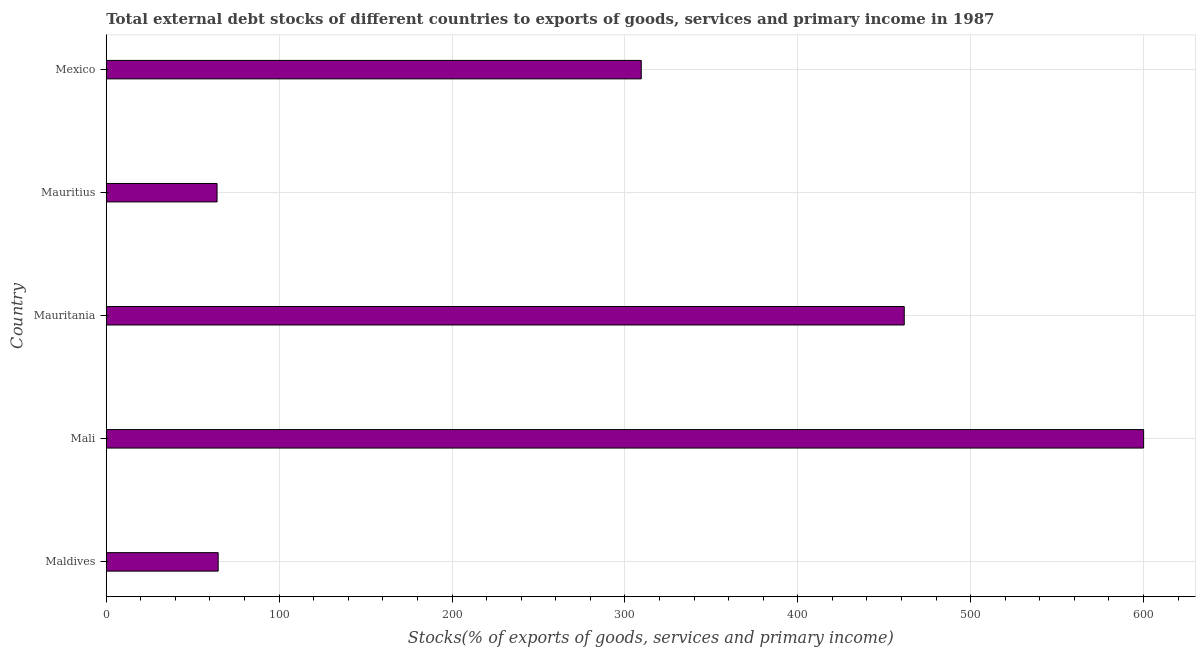Does the graph contain any zero values?
Your response must be concise. No. Does the graph contain grids?
Your answer should be compact. Yes. What is the title of the graph?
Offer a terse response. Total external debt stocks of different countries to exports of goods, services and primary income in 1987. What is the label or title of the X-axis?
Your response must be concise. Stocks(% of exports of goods, services and primary income). What is the external debt stocks in Mauritius?
Ensure brevity in your answer.  64.1. Across all countries, what is the maximum external debt stocks?
Provide a short and direct response. 600.04. Across all countries, what is the minimum external debt stocks?
Keep it short and to the point. 64.1. In which country was the external debt stocks maximum?
Your answer should be very brief. Mali. In which country was the external debt stocks minimum?
Keep it short and to the point. Mauritius. What is the sum of the external debt stocks?
Give a very brief answer. 1499.93. What is the difference between the external debt stocks in Mauritius and Mexico?
Make the answer very short. -245.37. What is the average external debt stocks per country?
Give a very brief answer. 299.99. What is the median external debt stocks?
Provide a short and direct response. 309.46. In how many countries, is the external debt stocks greater than 360 %?
Make the answer very short. 2. What is the ratio of the external debt stocks in Mauritania to that in Mauritius?
Provide a succinct answer. 7.2. Is the external debt stocks in Maldives less than that in Mauritius?
Provide a succinct answer. No. What is the difference between the highest and the second highest external debt stocks?
Give a very brief answer. 138.46. Is the sum of the external debt stocks in Maldives and Mauritius greater than the maximum external debt stocks across all countries?
Provide a succinct answer. No. What is the difference between the highest and the lowest external debt stocks?
Provide a succinct answer. 535.95. Are all the bars in the graph horizontal?
Give a very brief answer. Yes. How many countries are there in the graph?
Give a very brief answer. 5. What is the Stocks(% of exports of goods, services and primary income) of Maldives?
Provide a succinct answer. 64.74. What is the Stocks(% of exports of goods, services and primary income) of Mali?
Your answer should be very brief. 600.04. What is the Stocks(% of exports of goods, services and primary income) of Mauritania?
Make the answer very short. 461.58. What is the Stocks(% of exports of goods, services and primary income) of Mauritius?
Your response must be concise. 64.1. What is the Stocks(% of exports of goods, services and primary income) in Mexico?
Your response must be concise. 309.46. What is the difference between the Stocks(% of exports of goods, services and primary income) in Maldives and Mali?
Your response must be concise. -535.31. What is the difference between the Stocks(% of exports of goods, services and primary income) in Maldives and Mauritania?
Give a very brief answer. -396.85. What is the difference between the Stocks(% of exports of goods, services and primary income) in Maldives and Mauritius?
Your answer should be compact. 0.64. What is the difference between the Stocks(% of exports of goods, services and primary income) in Maldives and Mexico?
Provide a short and direct response. -244.73. What is the difference between the Stocks(% of exports of goods, services and primary income) in Mali and Mauritania?
Offer a very short reply. 138.46. What is the difference between the Stocks(% of exports of goods, services and primary income) in Mali and Mauritius?
Your answer should be very brief. 535.95. What is the difference between the Stocks(% of exports of goods, services and primary income) in Mali and Mexico?
Ensure brevity in your answer.  290.58. What is the difference between the Stocks(% of exports of goods, services and primary income) in Mauritania and Mauritius?
Give a very brief answer. 397.49. What is the difference between the Stocks(% of exports of goods, services and primary income) in Mauritania and Mexico?
Give a very brief answer. 152.12. What is the difference between the Stocks(% of exports of goods, services and primary income) in Mauritius and Mexico?
Your response must be concise. -245.37. What is the ratio of the Stocks(% of exports of goods, services and primary income) in Maldives to that in Mali?
Ensure brevity in your answer.  0.11. What is the ratio of the Stocks(% of exports of goods, services and primary income) in Maldives to that in Mauritania?
Your answer should be compact. 0.14. What is the ratio of the Stocks(% of exports of goods, services and primary income) in Maldives to that in Mexico?
Your response must be concise. 0.21. What is the ratio of the Stocks(% of exports of goods, services and primary income) in Mali to that in Mauritania?
Offer a terse response. 1.3. What is the ratio of the Stocks(% of exports of goods, services and primary income) in Mali to that in Mauritius?
Your answer should be compact. 9.36. What is the ratio of the Stocks(% of exports of goods, services and primary income) in Mali to that in Mexico?
Keep it short and to the point. 1.94. What is the ratio of the Stocks(% of exports of goods, services and primary income) in Mauritania to that in Mauritius?
Give a very brief answer. 7.2. What is the ratio of the Stocks(% of exports of goods, services and primary income) in Mauritania to that in Mexico?
Provide a short and direct response. 1.49. What is the ratio of the Stocks(% of exports of goods, services and primary income) in Mauritius to that in Mexico?
Your answer should be compact. 0.21. 